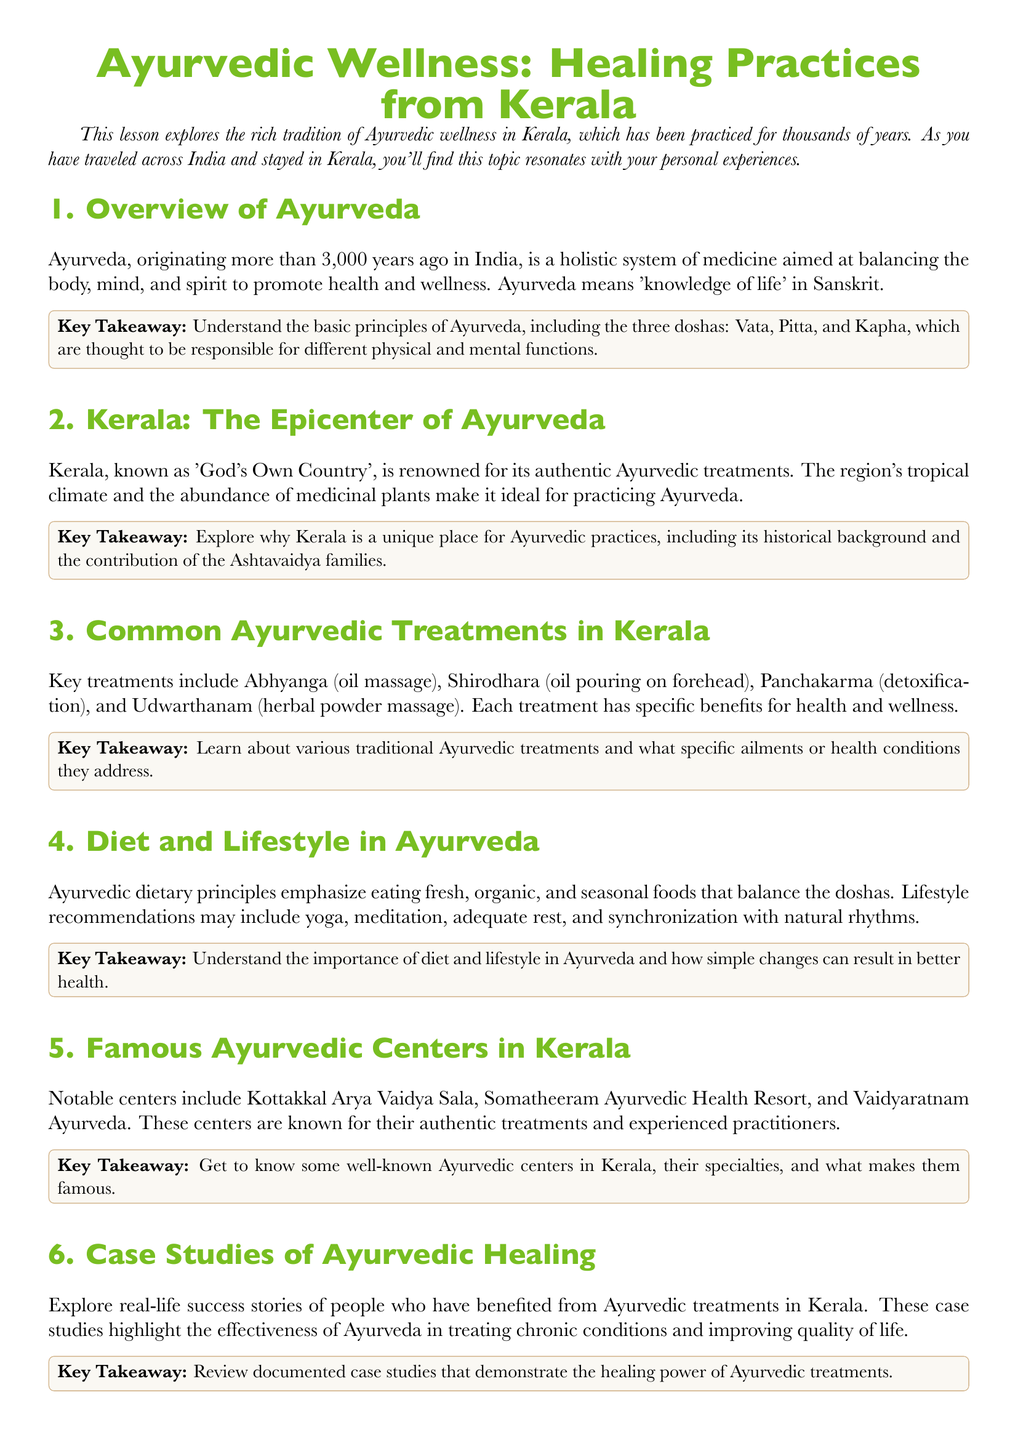What are the three doshas in Ayurveda? The document specifies that the three doshas are responsible for different physical and mental functions.
Answer: Vata, Pitta, Kapha What is the primary aim of Ayurveda? The document outlines that Ayurveda aims to balance the body, mind, and spirit to promote health and wellness.
Answer: Promotion of health and wellness Which treatment involves oil pouring on the forehead? The document lists Shirodhara as an Ayurvedic treatment involving this process.
Answer: Shirodhara What type of climate is ideal for practicing Ayurveda in Kerala? The document states that Kerala's tropical climate is particularly suited for Ayurvedic practices.
Answer: Tropical climate Name one notable Ayurvedic center in Kerala. The document mentions Kottakkal Arya Vaidya Sala as a notable center.
Answer: Kottakkal Arya Vaidya Sala What does the term "Panchakarma" refer to? The document describes Panchakarma as a detoxification treatment within Ayurveda.
Answer: Detoxification How long has Ayurveda been practiced? The document indicates that Ayurveda has been practiced for over 3,000 years.
Answer: Over 3,000 years Who contributed significantly to the Ayurvedic practices in Kerala? The document references the contribution of the Ashtavaidya families.
Answer: Ashtavaidya families What dietary principles does Ayurveda emphasize? The document emphasizes eating fresh, organic, and seasonal foods in Ayurveda.
Answer: Fresh, organic, seasonal foods 